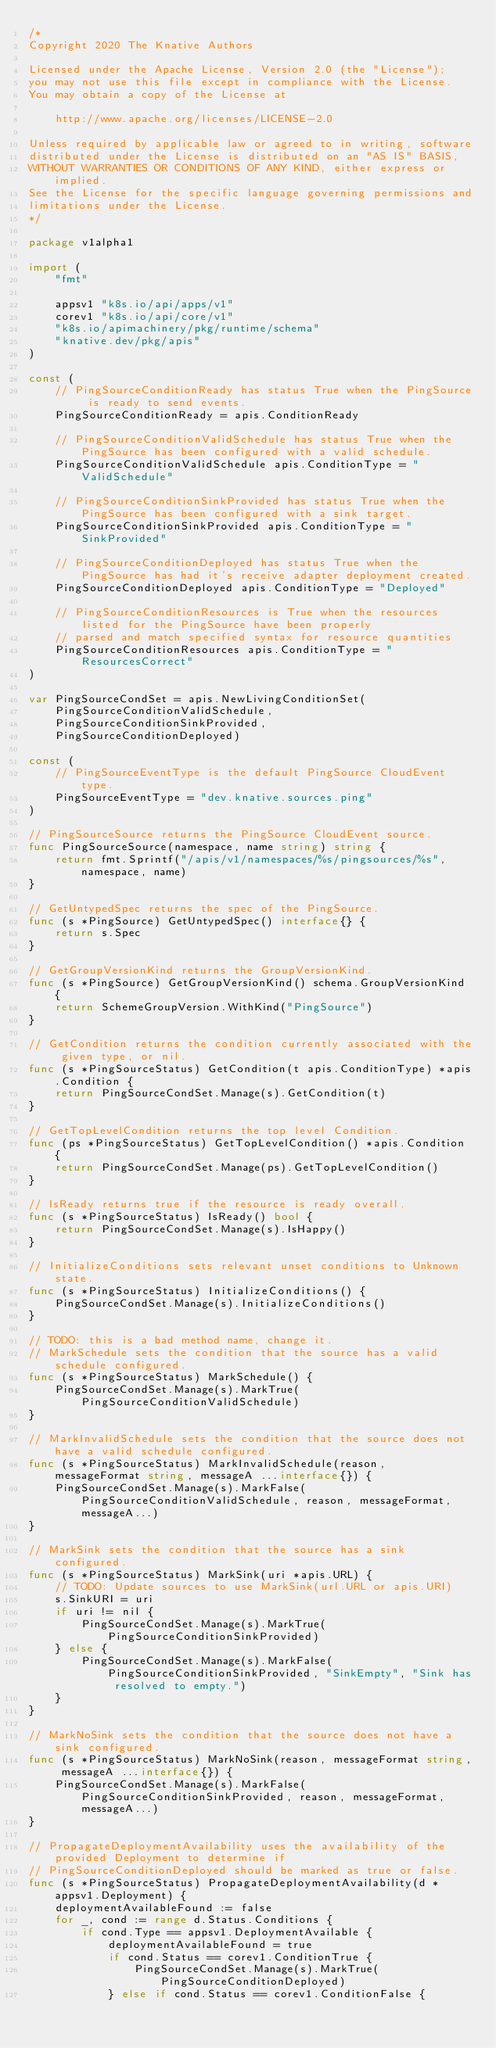Convert code to text. <code><loc_0><loc_0><loc_500><loc_500><_Go_>/*
Copyright 2020 The Knative Authors

Licensed under the Apache License, Version 2.0 (the "License");
you may not use this file except in compliance with the License.
You may obtain a copy of the License at

    http://www.apache.org/licenses/LICENSE-2.0

Unless required by applicable law or agreed to in writing, software
distributed under the License is distributed on an "AS IS" BASIS,
WITHOUT WARRANTIES OR CONDITIONS OF ANY KIND, either express or implied.
See the License for the specific language governing permissions and
limitations under the License.
*/

package v1alpha1

import (
	"fmt"

	appsv1 "k8s.io/api/apps/v1"
	corev1 "k8s.io/api/core/v1"
	"k8s.io/apimachinery/pkg/runtime/schema"
	"knative.dev/pkg/apis"
)

const (
	// PingSourceConditionReady has status True when the PingSource is ready to send events.
	PingSourceConditionReady = apis.ConditionReady

	// PingSourceConditionValidSchedule has status True when the PingSource has been configured with a valid schedule.
	PingSourceConditionValidSchedule apis.ConditionType = "ValidSchedule"

	// PingSourceConditionSinkProvided has status True when the PingSource has been configured with a sink target.
	PingSourceConditionSinkProvided apis.ConditionType = "SinkProvided"

	// PingSourceConditionDeployed has status True when the PingSource has had it's receive adapter deployment created.
	PingSourceConditionDeployed apis.ConditionType = "Deployed"

	// PingSourceConditionResources is True when the resources listed for the PingSource have been properly
	// parsed and match specified syntax for resource quantities
	PingSourceConditionResources apis.ConditionType = "ResourcesCorrect"
)

var PingSourceCondSet = apis.NewLivingConditionSet(
	PingSourceConditionValidSchedule,
	PingSourceConditionSinkProvided,
	PingSourceConditionDeployed)

const (
	// PingSourceEventType is the default PingSource CloudEvent type.
	PingSourceEventType = "dev.knative.sources.ping"
)

// PingSourceSource returns the PingSource CloudEvent source.
func PingSourceSource(namespace, name string) string {
	return fmt.Sprintf("/apis/v1/namespaces/%s/pingsources/%s", namespace, name)
}

// GetUntypedSpec returns the spec of the PingSource.
func (s *PingSource) GetUntypedSpec() interface{} {
	return s.Spec
}

// GetGroupVersionKind returns the GroupVersionKind.
func (s *PingSource) GetGroupVersionKind() schema.GroupVersionKind {
	return SchemeGroupVersion.WithKind("PingSource")
}

// GetCondition returns the condition currently associated with the given type, or nil.
func (s *PingSourceStatus) GetCondition(t apis.ConditionType) *apis.Condition {
	return PingSourceCondSet.Manage(s).GetCondition(t)
}

// GetTopLevelCondition returns the top level Condition.
func (ps *PingSourceStatus) GetTopLevelCondition() *apis.Condition {
	return PingSourceCondSet.Manage(ps).GetTopLevelCondition()
}

// IsReady returns true if the resource is ready overall.
func (s *PingSourceStatus) IsReady() bool {
	return PingSourceCondSet.Manage(s).IsHappy()
}

// InitializeConditions sets relevant unset conditions to Unknown state.
func (s *PingSourceStatus) InitializeConditions() {
	PingSourceCondSet.Manage(s).InitializeConditions()
}

// TODO: this is a bad method name, change it.
// MarkSchedule sets the condition that the source has a valid schedule configured.
func (s *PingSourceStatus) MarkSchedule() {
	PingSourceCondSet.Manage(s).MarkTrue(PingSourceConditionValidSchedule)
}

// MarkInvalidSchedule sets the condition that the source does not have a valid schedule configured.
func (s *PingSourceStatus) MarkInvalidSchedule(reason, messageFormat string, messageA ...interface{}) {
	PingSourceCondSet.Manage(s).MarkFalse(PingSourceConditionValidSchedule, reason, messageFormat, messageA...)
}

// MarkSink sets the condition that the source has a sink configured.
func (s *PingSourceStatus) MarkSink(uri *apis.URL) {
	// TODO: Update sources to use MarkSink(url.URL or apis.URI)
	s.SinkURI = uri
	if uri != nil {
		PingSourceCondSet.Manage(s).MarkTrue(PingSourceConditionSinkProvided)
	} else {
		PingSourceCondSet.Manage(s).MarkFalse(PingSourceConditionSinkProvided, "SinkEmpty", "Sink has resolved to empty.")
	}
}

// MarkNoSink sets the condition that the source does not have a sink configured.
func (s *PingSourceStatus) MarkNoSink(reason, messageFormat string, messageA ...interface{}) {
	PingSourceCondSet.Manage(s).MarkFalse(PingSourceConditionSinkProvided, reason, messageFormat, messageA...)
}

// PropagateDeploymentAvailability uses the availability of the provided Deployment to determine if
// PingSourceConditionDeployed should be marked as true or false.
func (s *PingSourceStatus) PropagateDeploymentAvailability(d *appsv1.Deployment) {
	deploymentAvailableFound := false
	for _, cond := range d.Status.Conditions {
		if cond.Type == appsv1.DeploymentAvailable {
			deploymentAvailableFound = true
			if cond.Status == corev1.ConditionTrue {
				PingSourceCondSet.Manage(s).MarkTrue(PingSourceConditionDeployed)
			} else if cond.Status == corev1.ConditionFalse {</code> 